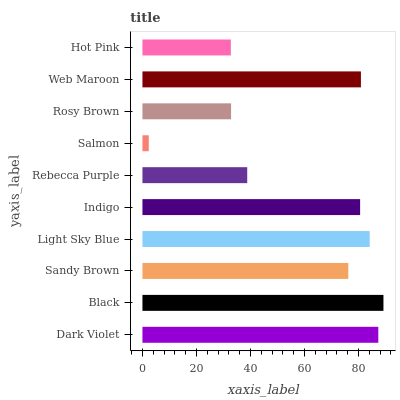Is Salmon the minimum?
Answer yes or no. Yes. Is Black the maximum?
Answer yes or no. Yes. Is Sandy Brown the minimum?
Answer yes or no. No. Is Sandy Brown the maximum?
Answer yes or no. No. Is Black greater than Sandy Brown?
Answer yes or no. Yes. Is Sandy Brown less than Black?
Answer yes or no. Yes. Is Sandy Brown greater than Black?
Answer yes or no. No. Is Black less than Sandy Brown?
Answer yes or no. No. Is Indigo the high median?
Answer yes or no. Yes. Is Sandy Brown the low median?
Answer yes or no. Yes. Is Light Sky Blue the high median?
Answer yes or no. No. Is Salmon the low median?
Answer yes or no. No. 